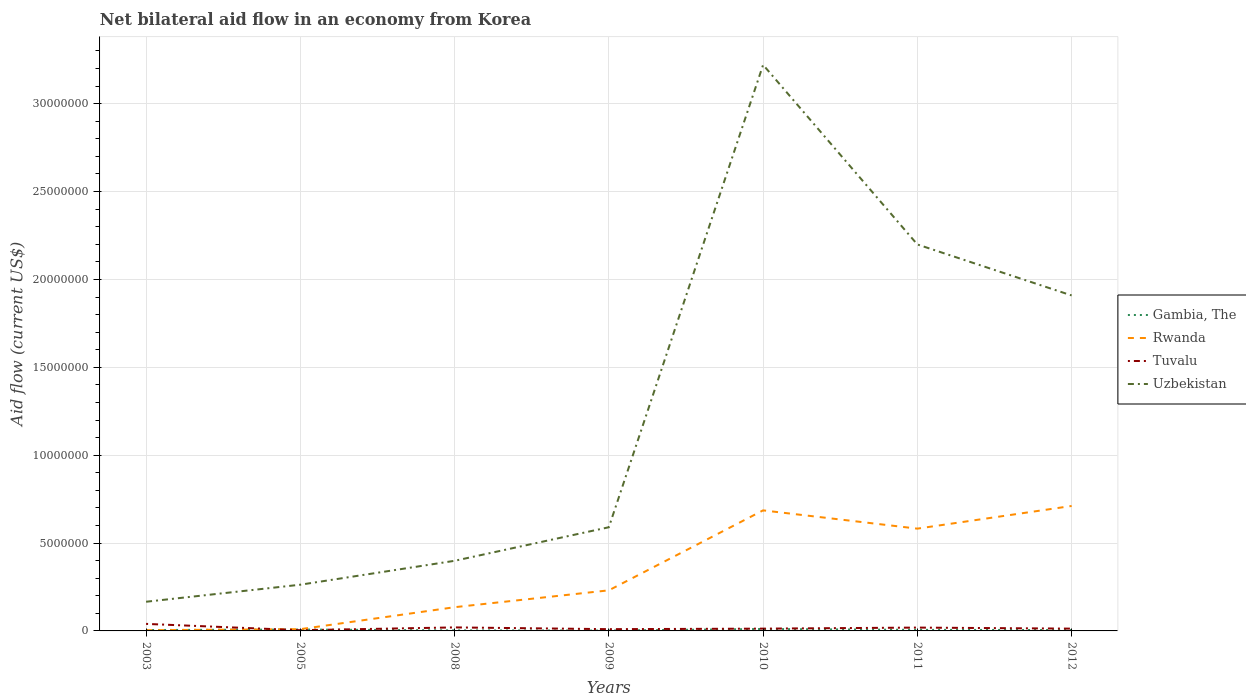How many different coloured lines are there?
Offer a very short reply. 4. Does the line corresponding to Uzbekistan intersect with the line corresponding to Tuvalu?
Keep it short and to the point. No. Across all years, what is the maximum net bilateral aid flow in Uzbekistan?
Make the answer very short. 1.66e+06. In which year was the net bilateral aid flow in Tuvalu maximum?
Keep it short and to the point. 2005. What is the total net bilateral aid flow in Rwanda in the graph?
Ensure brevity in your answer.  -4.47e+06. How many lines are there?
Your answer should be very brief. 4. How many years are there in the graph?
Your answer should be compact. 7. Are the values on the major ticks of Y-axis written in scientific E-notation?
Give a very brief answer. No. Does the graph contain grids?
Your answer should be very brief. Yes. Where does the legend appear in the graph?
Your response must be concise. Center right. How are the legend labels stacked?
Provide a short and direct response. Vertical. What is the title of the graph?
Provide a short and direct response. Net bilateral aid flow in an economy from Korea. Does "Kosovo" appear as one of the legend labels in the graph?
Ensure brevity in your answer.  No. What is the Aid flow (current US$) in Gambia, The in 2003?
Your answer should be very brief. 5.00e+04. What is the Aid flow (current US$) of Rwanda in 2003?
Offer a very short reply. 4.00e+04. What is the Aid flow (current US$) in Uzbekistan in 2003?
Offer a terse response. 1.66e+06. What is the Aid flow (current US$) of Gambia, The in 2005?
Provide a succinct answer. 8.00e+04. What is the Aid flow (current US$) of Uzbekistan in 2005?
Your response must be concise. 2.63e+06. What is the Aid flow (current US$) in Rwanda in 2008?
Ensure brevity in your answer.  1.35e+06. What is the Aid flow (current US$) of Tuvalu in 2008?
Make the answer very short. 2.00e+05. What is the Aid flow (current US$) of Uzbekistan in 2008?
Your answer should be very brief. 3.99e+06. What is the Aid flow (current US$) in Gambia, The in 2009?
Give a very brief answer. 2.00e+04. What is the Aid flow (current US$) of Rwanda in 2009?
Your answer should be compact. 2.31e+06. What is the Aid flow (current US$) in Tuvalu in 2009?
Offer a very short reply. 1.00e+05. What is the Aid flow (current US$) in Uzbekistan in 2009?
Your answer should be compact. 5.90e+06. What is the Aid flow (current US$) in Gambia, The in 2010?
Your answer should be compact. 1.10e+05. What is the Aid flow (current US$) in Rwanda in 2010?
Keep it short and to the point. 6.86e+06. What is the Aid flow (current US$) in Tuvalu in 2010?
Your answer should be compact. 1.30e+05. What is the Aid flow (current US$) of Uzbekistan in 2010?
Your answer should be very brief. 3.22e+07. What is the Aid flow (current US$) of Rwanda in 2011?
Offer a very short reply. 5.82e+06. What is the Aid flow (current US$) of Tuvalu in 2011?
Your answer should be compact. 1.90e+05. What is the Aid flow (current US$) of Uzbekistan in 2011?
Your answer should be compact. 2.20e+07. What is the Aid flow (current US$) in Gambia, The in 2012?
Offer a very short reply. 5.00e+04. What is the Aid flow (current US$) of Rwanda in 2012?
Offer a terse response. 7.11e+06. What is the Aid flow (current US$) in Tuvalu in 2012?
Your answer should be very brief. 1.30e+05. What is the Aid flow (current US$) of Uzbekistan in 2012?
Your answer should be very brief. 1.91e+07. Across all years, what is the maximum Aid flow (current US$) in Rwanda?
Ensure brevity in your answer.  7.11e+06. Across all years, what is the maximum Aid flow (current US$) in Tuvalu?
Ensure brevity in your answer.  4.00e+05. Across all years, what is the maximum Aid flow (current US$) of Uzbekistan?
Make the answer very short. 3.22e+07. Across all years, what is the minimum Aid flow (current US$) of Rwanda?
Provide a succinct answer. 4.00e+04. Across all years, what is the minimum Aid flow (current US$) of Tuvalu?
Offer a terse response. 4.00e+04. Across all years, what is the minimum Aid flow (current US$) in Uzbekistan?
Offer a very short reply. 1.66e+06. What is the total Aid flow (current US$) of Rwanda in the graph?
Offer a very short reply. 2.36e+07. What is the total Aid flow (current US$) in Tuvalu in the graph?
Make the answer very short. 1.19e+06. What is the total Aid flow (current US$) of Uzbekistan in the graph?
Ensure brevity in your answer.  8.75e+07. What is the difference between the Aid flow (current US$) in Rwanda in 2003 and that in 2005?
Your answer should be very brief. -6.00e+04. What is the difference between the Aid flow (current US$) of Uzbekistan in 2003 and that in 2005?
Offer a very short reply. -9.70e+05. What is the difference between the Aid flow (current US$) of Gambia, The in 2003 and that in 2008?
Your answer should be very brief. 2.00e+04. What is the difference between the Aid flow (current US$) in Rwanda in 2003 and that in 2008?
Make the answer very short. -1.31e+06. What is the difference between the Aid flow (current US$) in Uzbekistan in 2003 and that in 2008?
Make the answer very short. -2.33e+06. What is the difference between the Aid flow (current US$) of Rwanda in 2003 and that in 2009?
Your answer should be compact. -2.27e+06. What is the difference between the Aid flow (current US$) of Tuvalu in 2003 and that in 2009?
Provide a succinct answer. 3.00e+05. What is the difference between the Aid flow (current US$) in Uzbekistan in 2003 and that in 2009?
Keep it short and to the point. -4.24e+06. What is the difference between the Aid flow (current US$) in Gambia, The in 2003 and that in 2010?
Make the answer very short. -6.00e+04. What is the difference between the Aid flow (current US$) in Rwanda in 2003 and that in 2010?
Provide a short and direct response. -6.82e+06. What is the difference between the Aid flow (current US$) in Uzbekistan in 2003 and that in 2010?
Offer a terse response. -3.06e+07. What is the difference between the Aid flow (current US$) of Rwanda in 2003 and that in 2011?
Offer a very short reply. -5.78e+06. What is the difference between the Aid flow (current US$) in Tuvalu in 2003 and that in 2011?
Provide a succinct answer. 2.10e+05. What is the difference between the Aid flow (current US$) of Uzbekistan in 2003 and that in 2011?
Ensure brevity in your answer.  -2.03e+07. What is the difference between the Aid flow (current US$) of Rwanda in 2003 and that in 2012?
Provide a short and direct response. -7.07e+06. What is the difference between the Aid flow (current US$) in Tuvalu in 2003 and that in 2012?
Keep it short and to the point. 2.70e+05. What is the difference between the Aid flow (current US$) of Uzbekistan in 2003 and that in 2012?
Offer a very short reply. -1.74e+07. What is the difference between the Aid flow (current US$) in Gambia, The in 2005 and that in 2008?
Provide a succinct answer. 5.00e+04. What is the difference between the Aid flow (current US$) of Rwanda in 2005 and that in 2008?
Your response must be concise. -1.25e+06. What is the difference between the Aid flow (current US$) in Tuvalu in 2005 and that in 2008?
Give a very brief answer. -1.60e+05. What is the difference between the Aid flow (current US$) in Uzbekistan in 2005 and that in 2008?
Provide a succinct answer. -1.36e+06. What is the difference between the Aid flow (current US$) of Gambia, The in 2005 and that in 2009?
Provide a succinct answer. 6.00e+04. What is the difference between the Aid flow (current US$) of Rwanda in 2005 and that in 2009?
Offer a terse response. -2.21e+06. What is the difference between the Aid flow (current US$) in Uzbekistan in 2005 and that in 2009?
Your response must be concise. -3.27e+06. What is the difference between the Aid flow (current US$) of Gambia, The in 2005 and that in 2010?
Your answer should be very brief. -3.00e+04. What is the difference between the Aid flow (current US$) of Rwanda in 2005 and that in 2010?
Keep it short and to the point. -6.76e+06. What is the difference between the Aid flow (current US$) in Tuvalu in 2005 and that in 2010?
Your answer should be compact. -9.00e+04. What is the difference between the Aid flow (current US$) of Uzbekistan in 2005 and that in 2010?
Your answer should be compact. -2.96e+07. What is the difference between the Aid flow (current US$) of Rwanda in 2005 and that in 2011?
Ensure brevity in your answer.  -5.72e+06. What is the difference between the Aid flow (current US$) in Tuvalu in 2005 and that in 2011?
Keep it short and to the point. -1.50e+05. What is the difference between the Aid flow (current US$) in Uzbekistan in 2005 and that in 2011?
Ensure brevity in your answer.  -1.94e+07. What is the difference between the Aid flow (current US$) of Rwanda in 2005 and that in 2012?
Your response must be concise. -7.01e+06. What is the difference between the Aid flow (current US$) in Tuvalu in 2005 and that in 2012?
Offer a very short reply. -9.00e+04. What is the difference between the Aid flow (current US$) in Uzbekistan in 2005 and that in 2012?
Make the answer very short. -1.65e+07. What is the difference between the Aid flow (current US$) of Gambia, The in 2008 and that in 2009?
Keep it short and to the point. 10000. What is the difference between the Aid flow (current US$) of Rwanda in 2008 and that in 2009?
Offer a terse response. -9.60e+05. What is the difference between the Aid flow (current US$) of Tuvalu in 2008 and that in 2009?
Your response must be concise. 1.00e+05. What is the difference between the Aid flow (current US$) in Uzbekistan in 2008 and that in 2009?
Your answer should be compact. -1.91e+06. What is the difference between the Aid flow (current US$) of Rwanda in 2008 and that in 2010?
Your answer should be compact. -5.51e+06. What is the difference between the Aid flow (current US$) of Uzbekistan in 2008 and that in 2010?
Your response must be concise. -2.82e+07. What is the difference between the Aid flow (current US$) of Rwanda in 2008 and that in 2011?
Offer a terse response. -4.47e+06. What is the difference between the Aid flow (current US$) of Tuvalu in 2008 and that in 2011?
Your response must be concise. 10000. What is the difference between the Aid flow (current US$) of Uzbekistan in 2008 and that in 2011?
Provide a short and direct response. -1.80e+07. What is the difference between the Aid flow (current US$) of Gambia, The in 2008 and that in 2012?
Ensure brevity in your answer.  -2.00e+04. What is the difference between the Aid flow (current US$) of Rwanda in 2008 and that in 2012?
Offer a very short reply. -5.76e+06. What is the difference between the Aid flow (current US$) in Tuvalu in 2008 and that in 2012?
Give a very brief answer. 7.00e+04. What is the difference between the Aid flow (current US$) of Uzbekistan in 2008 and that in 2012?
Your answer should be very brief. -1.51e+07. What is the difference between the Aid flow (current US$) of Rwanda in 2009 and that in 2010?
Give a very brief answer. -4.55e+06. What is the difference between the Aid flow (current US$) of Uzbekistan in 2009 and that in 2010?
Provide a succinct answer. -2.63e+07. What is the difference between the Aid flow (current US$) of Gambia, The in 2009 and that in 2011?
Ensure brevity in your answer.  -4.00e+04. What is the difference between the Aid flow (current US$) in Rwanda in 2009 and that in 2011?
Give a very brief answer. -3.51e+06. What is the difference between the Aid flow (current US$) in Tuvalu in 2009 and that in 2011?
Your answer should be compact. -9.00e+04. What is the difference between the Aid flow (current US$) in Uzbekistan in 2009 and that in 2011?
Your answer should be very brief. -1.61e+07. What is the difference between the Aid flow (current US$) in Gambia, The in 2009 and that in 2012?
Offer a very short reply. -3.00e+04. What is the difference between the Aid flow (current US$) of Rwanda in 2009 and that in 2012?
Your answer should be very brief. -4.80e+06. What is the difference between the Aid flow (current US$) in Uzbekistan in 2009 and that in 2012?
Ensure brevity in your answer.  -1.32e+07. What is the difference between the Aid flow (current US$) in Rwanda in 2010 and that in 2011?
Provide a succinct answer. 1.04e+06. What is the difference between the Aid flow (current US$) of Uzbekistan in 2010 and that in 2011?
Provide a short and direct response. 1.02e+07. What is the difference between the Aid flow (current US$) of Gambia, The in 2010 and that in 2012?
Ensure brevity in your answer.  6.00e+04. What is the difference between the Aid flow (current US$) of Rwanda in 2010 and that in 2012?
Provide a short and direct response. -2.50e+05. What is the difference between the Aid flow (current US$) in Uzbekistan in 2010 and that in 2012?
Give a very brief answer. 1.31e+07. What is the difference between the Aid flow (current US$) of Gambia, The in 2011 and that in 2012?
Offer a very short reply. 10000. What is the difference between the Aid flow (current US$) in Rwanda in 2011 and that in 2012?
Make the answer very short. -1.29e+06. What is the difference between the Aid flow (current US$) of Uzbekistan in 2011 and that in 2012?
Offer a terse response. 2.90e+06. What is the difference between the Aid flow (current US$) of Gambia, The in 2003 and the Aid flow (current US$) of Uzbekistan in 2005?
Provide a succinct answer. -2.58e+06. What is the difference between the Aid flow (current US$) of Rwanda in 2003 and the Aid flow (current US$) of Uzbekistan in 2005?
Your response must be concise. -2.59e+06. What is the difference between the Aid flow (current US$) in Tuvalu in 2003 and the Aid flow (current US$) in Uzbekistan in 2005?
Keep it short and to the point. -2.23e+06. What is the difference between the Aid flow (current US$) in Gambia, The in 2003 and the Aid flow (current US$) in Rwanda in 2008?
Give a very brief answer. -1.30e+06. What is the difference between the Aid flow (current US$) of Gambia, The in 2003 and the Aid flow (current US$) of Tuvalu in 2008?
Offer a very short reply. -1.50e+05. What is the difference between the Aid flow (current US$) of Gambia, The in 2003 and the Aid flow (current US$) of Uzbekistan in 2008?
Offer a terse response. -3.94e+06. What is the difference between the Aid flow (current US$) in Rwanda in 2003 and the Aid flow (current US$) in Tuvalu in 2008?
Provide a short and direct response. -1.60e+05. What is the difference between the Aid flow (current US$) in Rwanda in 2003 and the Aid flow (current US$) in Uzbekistan in 2008?
Your response must be concise. -3.95e+06. What is the difference between the Aid flow (current US$) in Tuvalu in 2003 and the Aid flow (current US$) in Uzbekistan in 2008?
Keep it short and to the point. -3.59e+06. What is the difference between the Aid flow (current US$) of Gambia, The in 2003 and the Aid flow (current US$) of Rwanda in 2009?
Keep it short and to the point. -2.26e+06. What is the difference between the Aid flow (current US$) in Gambia, The in 2003 and the Aid flow (current US$) in Uzbekistan in 2009?
Your answer should be compact. -5.85e+06. What is the difference between the Aid flow (current US$) in Rwanda in 2003 and the Aid flow (current US$) in Uzbekistan in 2009?
Offer a terse response. -5.86e+06. What is the difference between the Aid flow (current US$) in Tuvalu in 2003 and the Aid flow (current US$) in Uzbekistan in 2009?
Your answer should be very brief. -5.50e+06. What is the difference between the Aid flow (current US$) of Gambia, The in 2003 and the Aid flow (current US$) of Rwanda in 2010?
Provide a succinct answer. -6.81e+06. What is the difference between the Aid flow (current US$) in Gambia, The in 2003 and the Aid flow (current US$) in Tuvalu in 2010?
Your response must be concise. -8.00e+04. What is the difference between the Aid flow (current US$) of Gambia, The in 2003 and the Aid flow (current US$) of Uzbekistan in 2010?
Provide a succinct answer. -3.22e+07. What is the difference between the Aid flow (current US$) in Rwanda in 2003 and the Aid flow (current US$) in Tuvalu in 2010?
Offer a terse response. -9.00e+04. What is the difference between the Aid flow (current US$) in Rwanda in 2003 and the Aid flow (current US$) in Uzbekistan in 2010?
Keep it short and to the point. -3.22e+07. What is the difference between the Aid flow (current US$) of Tuvalu in 2003 and the Aid flow (current US$) of Uzbekistan in 2010?
Ensure brevity in your answer.  -3.18e+07. What is the difference between the Aid flow (current US$) of Gambia, The in 2003 and the Aid flow (current US$) of Rwanda in 2011?
Provide a short and direct response. -5.77e+06. What is the difference between the Aid flow (current US$) of Gambia, The in 2003 and the Aid flow (current US$) of Tuvalu in 2011?
Your answer should be compact. -1.40e+05. What is the difference between the Aid flow (current US$) in Gambia, The in 2003 and the Aid flow (current US$) in Uzbekistan in 2011?
Ensure brevity in your answer.  -2.19e+07. What is the difference between the Aid flow (current US$) of Rwanda in 2003 and the Aid flow (current US$) of Tuvalu in 2011?
Ensure brevity in your answer.  -1.50e+05. What is the difference between the Aid flow (current US$) of Rwanda in 2003 and the Aid flow (current US$) of Uzbekistan in 2011?
Ensure brevity in your answer.  -2.20e+07. What is the difference between the Aid flow (current US$) in Tuvalu in 2003 and the Aid flow (current US$) in Uzbekistan in 2011?
Offer a terse response. -2.16e+07. What is the difference between the Aid flow (current US$) in Gambia, The in 2003 and the Aid flow (current US$) in Rwanda in 2012?
Your answer should be compact. -7.06e+06. What is the difference between the Aid flow (current US$) in Gambia, The in 2003 and the Aid flow (current US$) in Tuvalu in 2012?
Make the answer very short. -8.00e+04. What is the difference between the Aid flow (current US$) in Gambia, The in 2003 and the Aid flow (current US$) in Uzbekistan in 2012?
Ensure brevity in your answer.  -1.90e+07. What is the difference between the Aid flow (current US$) of Rwanda in 2003 and the Aid flow (current US$) of Uzbekistan in 2012?
Give a very brief answer. -1.90e+07. What is the difference between the Aid flow (current US$) in Tuvalu in 2003 and the Aid flow (current US$) in Uzbekistan in 2012?
Your answer should be very brief. -1.87e+07. What is the difference between the Aid flow (current US$) of Gambia, The in 2005 and the Aid flow (current US$) of Rwanda in 2008?
Ensure brevity in your answer.  -1.27e+06. What is the difference between the Aid flow (current US$) in Gambia, The in 2005 and the Aid flow (current US$) in Tuvalu in 2008?
Provide a short and direct response. -1.20e+05. What is the difference between the Aid flow (current US$) in Gambia, The in 2005 and the Aid flow (current US$) in Uzbekistan in 2008?
Your answer should be very brief. -3.91e+06. What is the difference between the Aid flow (current US$) of Rwanda in 2005 and the Aid flow (current US$) of Uzbekistan in 2008?
Offer a very short reply. -3.89e+06. What is the difference between the Aid flow (current US$) of Tuvalu in 2005 and the Aid flow (current US$) of Uzbekistan in 2008?
Keep it short and to the point. -3.95e+06. What is the difference between the Aid flow (current US$) in Gambia, The in 2005 and the Aid flow (current US$) in Rwanda in 2009?
Offer a very short reply. -2.23e+06. What is the difference between the Aid flow (current US$) of Gambia, The in 2005 and the Aid flow (current US$) of Uzbekistan in 2009?
Provide a short and direct response. -5.82e+06. What is the difference between the Aid flow (current US$) in Rwanda in 2005 and the Aid flow (current US$) in Uzbekistan in 2009?
Your answer should be compact. -5.80e+06. What is the difference between the Aid flow (current US$) of Tuvalu in 2005 and the Aid flow (current US$) of Uzbekistan in 2009?
Your answer should be compact. -5.86e+06. What is the difference between the Aid flow (current US$) in Gambia, The in 2005 and the Aid flow (current US$) in Rwanda in 2010?
Offer a very short reply. -6.78e+06. What is the difference between the Aid flow (current US$) of Gambia, The in 2005 and the Aid flow (current US$) of Tuvalu in 2010?
Keep it short and to the point. -5.00e+04. What is the difference between the Aid flow (current US$) in Gambia, The in 2005 and the Aid flow (current US$) in Uzbekistan in 2010?
Your response must be concise. -3.21e+07. What is the difference between the Aid flow (current US$) in Rwanda in 2005 and the Aid flow (current US$) in Tuvalu in 2010?
Ensure brevity in your answer.  -3.00e+04. What is the difference between the Aid flow (current US$) of Rwanda in 2005 and the Aid flow (current US$) of Uzbekistan in 2010?
Offer a very short reply. -3.21e+07. What is the difference between the Aid flow (current US$) of Tuvalu in 2005 and the Aid flow (current US$) of Uzbekistan in 2010?
Give a very brief answer. -3.22e+07. What is the difference between the Aid flow (current US$) in Gambia, The in 2005 and the Aid flow (current US$) in Rwanda in 2011?
Provide a short and direct response. -5.74e+06. What is the difference between the Aid flow (current US$) of Gambia, The in 2005 and the Aid flow (current US$) of Uzbekistan in 2011?
Your answer should be very brief. -2.19e+07. What is the difference between the Aid flow (current US$) in Rwanda in 2005 and the Aid flow (current US$) in Uzbekistan in 2011?
Your response must be concise. -2.19e+07. What is the difference between the Aid flow (current US$) in Tuvalu in 2005 and the Aid flow (current US$) in Uzbekistan in 2011?
Make the answer very short. -2.20e+07. What is the difference between the Aid flow (current US$) in Gambia, The in 2005 and the Aid flow (current US$) in Rwanda in 2012?
Give a very brief answer. -7.03e+06. What is the difference between the Aid flow (current US$) in Gambia, The in 2005 and the Aid flow (current US$) in Uzbekistan in 2012?
Make the answer very short. -1.90e+07. What is the difference between the Aid flow (current US$) in Rwanda in 2005 and the Aid flow (current US$) in Tuvalu in 2012?
Provide a short and direct response. -3.00e+04. What is the difference between the Aid flow (current US$) in Rwanda in 2005 and the Aid flow (current US$) in Uzbekistan in 2012?
Offer a very short reply. -1.90e+07. What is the difference between the Aid flow (current US$) in Tuvalu in 2005 and the Aid flow (current US$) in Uzbekistan in 2012?
Your answer should be very brief. -1.90e+07. What is the difference between the Aid flow (current US$) in Gambia, The in 2008 and the Aid flow (current US$) in Rwanda in 2009?
Make the answer very short. -2.28e+06. What is the difference between the Aid flow (current US$) in Gambia, The in 2008 and the Aid flow (current US$) in Uzbekistan in 2009?
Your answer should be very brief. -5.87e+06. What is the difference between the Aid flow (current US$) in Rwanda in 2008 and the Aid flow (current US$) in Tuvalu in 2009?
Offer a terse response. 1.25e+06. What is the difference between the Aid flow (current US$) of Rwanda in 2008 and the Aid flow (current US$) of Uzbekistan in 2009?
Offer a terse response. -4.55e+06. What is the difference between the Aid flow (current US$) in Tuvalu in 2008 and the Aid flow (current US$) in Uzbekistan in 2009?
Your answer should be compact. -5.70e+06. What is the difference between the Aid flow (current US$) of Gambia, The in 2008 and the Aid flow (current US$) of Rwanda in 2010?
Your answer should be very brief. -6.83e+06. What is the difference between the Aid flow (current US$) in Gambia, The in 2008 and the Aid flow (current US$) in Uzbekistan in 2010?
Provide a short and direct response. -3.22e+07. What is the difference between the Aid flow (current US$) in Rwanda in 2008 and the Aid flow (current US$) in Tuvalu in 2010?
Provide a short and direct response. 1.22e+06. What is the difference between the Aid flow (current US$) of Rwanda in 2008 and the Aid flow (current US$) of Uzbekistan in 2010?
Offer a terse response. -3.09e+07. What is the difference between the Aid flow (current US$) of Tuvalu in 2008 and the Aid flow (current US$) of Uzbekistan in 2010?
Your answer should be very brief. -3.20e+07. What is the difference between the Aid flow (current US$) in Gambia, The in 2008 and the Aid flow (current US$) in Rwanda in 2011?
Offer a terse response. -5.79e+06. What is the difference between the Aid flow (current US$) in Gambia, The in 2008 and the Aid flow (current US$) in Uzbekistan in 2011?
Ensure brevity in your answer.  -2.20e+07. What is the difference between the Aid flow (current US$) of Rwanda in 2008 and the Aid flow (current US$) of Tuvalu in 2011?
Offer a very short reply. 1.16e+06. What is the difference between the Aid flow (current US$) of Rwanda in 2008 and the Aid flow (current US$) of Uzbekistan in 2011?
Provide a succinct answer. -2.06e+07. What is the difference between the Aid flow (current US$) of Tuvalu in 2008 and the Aid flow (current US$) of Uzbekistan in 2011?
Give a very brief answer. -2.18e+07. What is the difference between the Aid flow (current US$) in Gambia, The in 2008 and the Aid flow (current US$) in Rwanda in 2012?
Make the answer very short. -7.08e+06. What is the difference between the Aid flow (current US$) of Gambia, The in 2008 and the Aid flow (current US$) of Uzbekistan in 2012?
Provide a short and direct response. -1.91e+07. What is the difference between the Aid flow (current US$) of Rwanda in 2008 and the Aid flow (current US$) of Tuvalu in 2012?
Keep it short and to the point. 1.22e+06. What is the difference between the Aid flow (current US$) in Rwanda in 2008 and the Aid flow (current US$) in Uzbekistan in 2012?
Ensure brevity in your answer.  -1.77e+07. What is the difference between the Aid flow (current US$) in Tuvalu in 2008 and the Aid flow (current US$) in Uzbekistan in 2012?
Provide a succinct answer. -1.89e+07. What is the difference between the Aid flow (current US$) of Gambia, The in 2009 and the Aid flow (current US$) of Rwanda in 2010?
Your response must be concise. -6.84e+06. What is the difference between the Aid flow (current US$) of Gambia, The in 2009 and the Aid flow (current US$) of Uzbekistan in 2010?
Keep it short and to the point. -3.22e+07. What is the difference between the Aid flow (current US$) in Rwanda in 2009 and the Aid flow (current US$) in Tuvalu in 2010?
Provide a short and direct response. 2.18e+06. What is the difference between the Aid flow (current US$) in Rwanda in 2009 and the Aid flow (current US$) in Uzbekistan in 2010?
Give a very brief answer. -2.99e+07. What is the difference between the Aid flow (current US$) in Tuvalu in 2009 and the Aid flow (current US$) in Uzbekistan in 2010?
Make the answer very short. -3.21e+07. What is the difference between the Aid flow (current US$) in Gambia, The in 2009 and the Aid flow (current US$) in Rwanda in 2011?
Keep it short and to the point. -5.80e+06. What is the difference between the Aid flow (current US$) in Gambia, The in 2009 and the Aid flow (current US$) in Tuvalu in 2011?
Your response must be concise. -1.70e+05. What is the difference between the Aid flow (current US$) of Gambia, The in 2009 and the Aid flow (current US$) of Uzbekistan in 2011?
Keep it short and to the point. -2.20e+07. What is the difference between the Aid flow (current US$) in Rwanda in 2009 and the Aid flow (current US$) in Tuvalu in 2011?
Your answer should be compact. 2.12e+06. What is the difference between the Aid flow (current US$) of Rwanda in 2009 and the Aid flow (current US$) of Uzbekistan in 2011?
Provide a short and direct response. -1.97e+07. What is the difference between the Aid flow (current US$) in Tuvalu in 2009 and the Aid flow (current US$) in Uzbekistan in 2011?
Your answer should be very brief. -2.19e+07. What is the difference between the Aid flow (current US$) of Gambia, The in 2009 and the Aid flow (current US$) of Rwanda in 2012?
Give a very brief answer. -7.09e+06. What is the difference between the Aid flow (current US$) of Gambia, The in 2009 and the Aid flow (current US$) of Tuvalu in 2012?
Offer a very short reply. -1.10e+05. What is the difference between the Aid flow (current US$) of Gambia, The in 2009 and the Aid flow (current US$) of Uzbekistan in 2012?
Offer a very short reply. -1.91e+07. What is the difference between the Aid flow (current US$) of Rwanda in 2009 and the Aid flow (current US$) of Tuvalu in 2012?
Your answer should be compact. 2.18e+06. What is the difference between the Aid flow (current US$) in Rwanda in 2009 and the Aid flow (current US$) in Uzbekistan in 2012?
Provide a short and direct response. -1.68e+07. What is the difference between the Aid flow (current US$) of Tuvalu in 2009 and the Aid flow (current US$) of Uzbekistan in 2012?
Keep it short and to the point. -1.90e+07. What is the difference between the Aid flow (current US$) in Gambia, The in 2010 and the Aid flow (current US$) in Rwanda in 2011?
Your answer should be very brief. -5.71e+06. What is the difference between the Aid flow (current US$) in Gambia, The in 2010 and the Aid flow (current US$) in Tuvalu in 2011?
Ensure brevity in your answer.  -8.00e+04. What is the difference between the Aid flow (current US$) in Gambia, The in 2010 and the Aid flow (current US$) in Uzbekistan in 2011?
Make the answer very short. -2.19e+07. What is the difference between the Aid flow (current US$) of Rwanda in 2010 and the Aid flow (current US$) of Tuvalu in 2011?
Provide a succinct answer. 6.67e+06. What is the difference between the Aid flow (current US$) of Rwanda in 2010 and the Aid flow (current US$) of Uzbekistan in 2011?
Ensure brevity in your answer.  -1.51e+07. What is the difference between the Aid flow (current US$) of Tuvalu in 2010 and the Aid flow (current US$) of Uzbekistan in 2011?
Ensure brevity in your answer.  -2.19e+07. What is the difference between the Aid flow (current US$) in Gambia, The in 2010 and the Aid flow (current US$) in Rwanda in 2012?
Your answer should be compact. -7.00e+06. What is the difference between the Aid flow (current US$) of Gambia, The in 2010 and the Aid flow (current US$) of Uzbekistan in 2012?
Make the answer very short. -1.90e+07. What is the difference between the Aid flow (current US$) of Rwanda in 2010 and the Aid flow (current US$) of Tuvalu in 2012?
Make the answer very short. 6.73e+06. What is the difference between the Aid flow (current US$) of Rwanda in 2010 and the Aid flow (current US$) of Uzbekistan in 2012?
Provide a short and direct response. -1.22e+07. What is the difference between the Aid flow (current US$) of Tuvalu in 2010 and the Aid flow (current US$) of Uzbekistan in 2012?
Give a very brief answer. -1.90e+07. What is the difference between the Aid flow (current US$) in Gambia, The in 2011 and the Aid flow (current US$) in Rwanda in 2012?
Your answer should be very brief. -7.05e+06. What is the difference between the Aid flow (current US$) in Gambia, The in 2011 and the Aid flow (current US$) in Uzbekistan in 2012?
Provide a short and direct response. -1.90e+07. What is the difference between the Aid flow (current US$) of Rwanda in 2011 and the Aid flow (current US$) of Tuvalu in 2012?
Your response must be concise. 5.69e+06. What is the difference between the Aid flow (current US$) of Rwanda in 2011 and the Aid flow (current US$) of Uzbekistan in 2012?
Your response must be concise. -1.33e+07. What is the difference between the Aid flow (current US$) of Tuvalu in 2011 and the Aid flow (current US$) of Uzbekistan in 2012?
Provide a short and direct response. -1.89e+07. What is the average Aid flow (current US$) in Gambia, The per year?
Give a very brief answer. 5.71e+04. What is the average Aid flow (current US$) of Rwanda per year?
Provide a short and direct response. 3.37e+06. What is the average Aid flow (current US$) in Uzbekistan per year?
Ensure brevity in your answer.  1.25e+07. In the year 2003, what is the difference between the Aid flow (current US$) in Gambia, The and Aid flow (current US$) in Rwanda?
Your answer should be very brief. 10000. In the year 2003, what is the difference between the Aid flow (current US$) in Gambia, The and Aid flow (current US$) in Tuvalu?
Ensure brevity in your answer.  -3.50e+05. In the year 2003, what is the difference between the Aid flow (current US$) in Gambia, The and Aid flow (current US$) in Uzbekistan?
Make the answer very short. -1.61e+06. In the year 2003, what is the difference between the Aid flow (current US$) in Rwanda and Aid flow (current US$) in Tuvalu?
Offer a terse response. -3.60e+05. In the year 2003, what is the difference between the Aid flow (current US$) of Rwanda and Aid flow (current US$) of Uzbekistan?
Provide a short and direct response. -1.62e+06. In the year 2003, what is the difference between the Aid flow (current US$) in Tuvalu and Aid flow (current US$) in Uzbekistan?
Provide a short and direct response. -1.26e+06. In the year 2005, what is the difference between the Aid flow (current US$) of Gambia, The and Aid flow (current US$) of Tuvalu?
Provide a succinct answer. 4.00e+04. In the year 2005, what is the difference between the Aid flow (current US$) in Gambia, The and Aid flow (current US$) in Uzbekistan?
Your answer should be very brief. -2.55e+06. In the year 2005, what is the difference between the Aid flow (current US$) in Rwanda and Aid flow (current US$) in Tuvalu?
Offer a terse response. 6.00e+04. In the year 2005, what is the difference between the Aid flow (current US$) in Rwanda and Aid flow (current US$) in Uzbekistan?
Give a very brief answer. -2.53e+06. In the year 2005, what is the difference between the Aid flow (current US$) in Tuvalu and Aid flow (current US$) in Uzbekistan?
Your answer should be very brief. -2.59e+06. In the year 2008, what is the difference between the Aid flow (current US$) of Gambia, The and Aid flow (current US$) of Rwanda?
Your answer should be compact. -1.32e+06. In the year 2008, what is the difference between the Aid flow (current US$) in Gambia, The and Aid flow (current US$) in Tuvalu?
Provide a short and direct response. -1.70e+05. In the year 2008, what is the difference between the Aid flow (current US$) in Gambia, The and Aid flow (current US$) in Uzbekistan?
Ensure brevity in your answer.  -3.96e+06. In the year 2008, what is the difference between the Aid flow (current US$) of Rwanda and Aid flow (current US$) of Tuvalu?
Provide a short and direct response. 1.15e+06. In the year 2008, what is the difference between the Aid flow (current US$) in Rwanda and Aid flow (current US$) in Uzbekistan?
Offer a terse response. -2.64e+06. In the year 2008, what is the difference between the Aid flow (current US$) in Tuvalu and Aid flow (current US$) in Uzbekistan?
Your response must be concise. -3.79e+06. In the year 2009, what is the difference between the Aid flow (current US$) of Gambia, The and Aid flow (current US$) of Rwanda?
Ensure brevity in your answer.  -2.29e+06. In the year 2009, what is the difference between the Aid flow (current US$) in Gambia, The and Aid flow (current US$) in Uzbekistan?
Provide a succinct answer. -5.88e+06. In the year 2009, what is the difference between the Aid flow (current US$) in Rwanda and Aid flow (current US$) in Tuvalu?
Your response must be concise. 2.21e+06. In the year 2009, what is the difference between the Aid flow (current US$) of Rwanda and Aid flow (current US$) of Uzbekistan?
Your answer should be compact. -3.59e+06. In the year 2009, what is the difference between the Aid flow (current US$) of Tuvalu and Aid flow (current US$) of Uzbekistan?
Ensure brevity in your answer.  -5.80e+06. In the year 2010, what is the difference between the Aid flow (current US$) of Gambia, The and Aid flow (current US$) of Rwanda?
Give a very brief answer. -6.75e+06. In the year 2010, what is the difference between the Aid flow (current US$) of Gambia, The and Aid flow (current US$) of Uzbekistan?
Keep it short and to the point. -3.21e+07. In the year 2010, what is the difference between the Aid flow (current US$) in Rwanda and Aid flow (current US$) in Tuvalu?
Provide a short and direct response. 6.73e+06. In the year 2010, what is the difference between the Aid flow (current US$) in Rwanda and Aid flow (current US$) in Uzbekistan?
Keep it short and to the point. -2.54e+07. In the year 2010, what is the difference between the Aid flow (current US$) in Tuvalu and Aid flow (current US$) in Uzbekistan?
Ensure brevity in your answer.  -3.21e+07. In the year 2011, what is the difference between the Aid flow (current US$) in Gambia, The and Aid flow (current US$) in Rwanda?
Ensure brevity in your answer.  -5.76e+06. In the year 2011, what is the difference between the Aid flow (current US$) in Gambia, The and Aid flow (current US$) in Tuvalu?
Your response must be concise. -1.30e+05. In the year 2011, what is the difference between the Aid flow (current US$) of Gambia, The and Aid flow (current US$) of Uzbekistan?
Provide a short and direct response. -2.19e+07. In the year 2011, what is the difference between the Aid flow (current US$) of Rwanda and Aid flow (current US$) of Tuvalu?
Provide a short and direct response. 5.63e+06. In the year 2011, what is the difference between the Aid flow (current US$) of Rwanda and Aid flow (current US$) of Uzbekistan?
Offer a very short reply. -1.62e+07. In the year 2011, what is the difference between the Aid flow (current US$) of Tuvalu and Aid flow (current US$) of Uzbekistan?
Your response must be concise. -2.18e+07. In the year 2012, what is the difference between the Aid flow (current US$) in Gambia, The and Aid flow (current US$) in Rwanda?
Give a very brief answer. -7.06e+06. In the year 2012, what is the difference between the Aid flow (current US$) of Gambia, The and Aid flow (current US$) of Tuvalu?
Provide a succinct answer. -8.00e+04. In the year 2012, what is the difference between the Aid flow (current US$) in Gambia, The and Aid flow (current US$) in Uzbekistan?
Provide a short and direct response. -1.90e+07. In the year 2012, what is the difference between the Aid flow (current US$) of Rwanda and Aid flow (current US$) of Tuvalu?
Your response must be concise. 6.98e+06. In the year 2012, what is the difference between the Aid flow (current US$) in Rwanda and Aid flow (current US$) in Uzbekistan?
Your response must be concise. -1.20e+07. In the year 2012, what is the difference between the Aid flow (current US$) in Tuvalu and Aid flow (current US$) in Uzbekistan?
Your response must be concise. -1.90e+07. What is the ratio of the Aid flow (current US$) in Gambia, The in 2003 to that in 2005?
Your answer should be very brief. 0.62. What is the ratio of the Aid flow (current US$) of Tuvalu in 2003 to that in 2005?
Ensure brevity in your answer.  10. What is the ratio of the Aid flow (current US$) in Uzbekistan in 2003 to that in 2005?
Your answer should be very brief. 0.63. What is the ratio of the Aid flow (current US$) in Rwanda in 2003 to that in 2008?
Offer a very short reply. 0.03. What is the ratio of the Aid flow (current US$) in Uzbekistan in 2003 to that in 2008?
Give a very brief answer. 0.42. What is the ratio of the Aid flow (current US$) of Gambia, The in 2003 to that in 2009?
Give a very brief answer. 2.5. What is the ratio of the Aid flow (current US$) of Rwanda in 2003 to that in 2009?
Your answer should be compact. 0.02. What is the ratio of the Aid flow (current US$) of Uzbekistan in 2003 to that in 2009?
Provide a succinct answer. 0.28. What is the ratio of the Aid flow (current US$) of Gambia, The in 2003 to that in 2010?
Your answer should be very brief. 0.45. What is the ratio of the Aid flow (current US$) of Rwanda in 2003 to that in 2010?
Make the answer very short. 0.01. What is the ratio of the Aid flow (current US$) of Tuvalu in 2003 to that in 2010?
Your answer should be compact. 3.08. What is the ratio of the Aid flow (current US$) of Uzbekistan in 2003 to that in 2010?
Keep it short and to the point. 0.05. What is the ratio of the Aid flow (current US$) of Rwanda in 2003 to that in 2011?
Make the answer very short. 0.01. What is the ratio of the Aid flow (current US$) in Tuvalu in 2003 to that in 2011?
Provide a succinct answer. 2.11. What is the ratio of the Aid flow (current US$) of Uzbekistan in 2003 to that in 2011?
Provide a succinct answer. 0.08. What is the ratio of the Aid flow (current US$) in Rwanda in 2003 to that in 2012?
Provide a succinct answer. 0.01. What is the ratio of the Aid flow (current US$) of Tuvalu in 2003 to that in 2012?
Your response must be concise. 3.08. What is the ratio of the Aid flow (current US$) of Uzbekistan in 2003 to that in 2012?
Provide a succinct answer. 0.09. What is the ratio of the Aid flow (current US$) in Gambia, The in 2005 to that in 2008?
Your answer should be very brief. 2.67. What is the ratio of the Aid flow (current US$) of Rwanda in 2005 to that in 2008?
Your response must be concise. 0.07. What is the ratio of the Aid flow (current US$) in Uzbekistan in 2005 to that in 2008?
Keep it short and to the point. 0.66. What is the ratio of the Aid flow (current US$) in Gambia, The in 2005 to that in 2009?
Your answer should be very brief. 4. What is the ratio of the Aid flow (current US$) of Rwanda in 2005 to that in 2009?
Your response must be concise. 0.04. What is the ratio of the Aid flow (current US$) in Tuvalu in 2005 to that in 2009?
Provide a succinct answer. 0.4. What is the ratio of the Aid flow (current US$) of Uzbekistan in 2005 to that in 2009?
Your response must be concise. 0.45. What is the ratio of the Aid flow (current US$) of Gambia, The in 2005 to that in 2010?
Your answer should be very brief. 0.73. What is the ratio of the Aid flow (current US$) of Rwanda in 2005 to that in 2010?
Keep it short and to the point. 0.01. What is the ratio of the Aid flow (current US$) in Tuvalu in 2005 to that in 2010?
Your answer should be very brief. 0.31. What is the ratio of the Aid flow (current US$) in Uzbekistan in 2005 to that in 2010?
Provide a succinct answer. 0.08. What is the ratio of the Aid flow (current US$) in Rwanda in 2005 to that in 2011?
Provide a succinct answer. 0.02. What is the ratio of the Aid flow (current US$) of Tuvalu in 2005 to that in 2011?
Offer a terse response. 0.21. What is the ratio of the Aid flow (current US$) in Uzbekistan in 2005 to that in 2011?
Keep it short and to the point. 0.12. What is the ratio of the Aid flow (current US$) of Rwanda in 2005 to that in 2012?
Make the answer very short. 0.01. What is the ratio of the Aid flow (current US$) of Tuvalu in 2005 to that in 2012?
Give a very brief answer. 0.31. What is the ratio of the Aid flow (current US$) in Uzbekistan in 2005 to that in 2012?
Provide a succinct answer. 0.14. What is the ratio of the Aid flow (current US$) in Gambia, The in 2008 to that in 2009?
Offer a very short reply. 1.5. What is the ratio of the Aid flow (current US$) of Rwanda in 2008 to that in 2009?
Your answer should be very brief. 0.58. What is the ratio of the Aid flow (current US$) in Uzbekistan in 2008 to that in 2009?
Your response must be concise. 0.68. What is the ratio of the Aid flow (current US$) in Gambia, The in 2008 to that in 2010?
Provide a short and direct response. 0.27. What is the ratio of the Aid flow (current US$) of Rwanda in 2008 to that in 2010?
Keep it short and to the point. 0.2. What is the ratio of the Aid flow (current US$) of Tuvalu in 2008 to that in 2010?
Ensure brevity in your answer.  1.54. What is the ratio of the Aid flow (current US$) of Uzbekistan in 2008 to that in 2010?
Provide a succinct answer. 0.12. What is the ratio of the Aid flow (current US$) of Gambia, The in 2008 to that in 2011?
Ensure brevity in your answer.  0.5. What is the ratio of the Aid flow (current US$) in Rwanda in 2008 to that in 2011?
Your response must be concise. 0.23. What is the ratio of the Aid flow (current US$) of Tuvalu in 2008 to that in 2011?
Offer a terse response. 1.05. What is the ratio of the Aid flow (current US$) in Uzbekistan in 2008 to that in 2011?
Your answer should be compact. 0.18. What is the ratio of the Aid flow (current US$) in Gambia, The in 2008 to that in 2012?
Keep it short and to the point. 0.6. What is the ratio of the Aid flow (current US$) in Rwanda in 2008 to that in 2012?
Ensure brevity in your answer.  0.19. What is the ratio of the Aid flow (current US$) in Tuvalu in 2008 to that in 2012?
Offer a terse response. 1.54. What is the ratio of the Aid flow (current US$) in Uzbekistan in 2008 to that in 2012?
Your answer should be very brief. 0.21. What is the ratio of the Aid flow (current US$) of Gambia, The in 2009 to that in 2010?
Give a very brief answer. 0.18. What is the ratio of the Aid flow (current US$) of Rwanda in 2009 to that in 2010?
Your answer should be very brief. 0.34. What is the ratio of the Aid flow (current US$) in Tuvalu in 2009 to that in 2010?
Provide a short and direct response. 0.77. What is the ratio of the Aid flow (current US$) in Uzbekistan in 2009 to that in 2010?
Your answer should be very brief. 0.18. What is the ratio of the Aid flow (current US$) in Gambia, The in 2009 to that in 2011?
Your response must be concise. 0.33. What is the ratio of the Aid flow (current US$) in Rwanda in 2009 to that in 2011?
Offer a very short reply. 0.4. What is the ratio of the Aid flow (current US$) of Tuvalu in 2009 to that in 2011?
Make the answer very short. 0.53. What is the ratio of the Aid flow (current US$) of Uzbekistan in 2009 to that in 2011?
Provide a succinct answer. 0.27. What is the ratio of the Aid flow (current US$) in Gambia, The in 2009 to that in 2012?
Offer a very short reply. 0.4. What is the ratio of the Aid flow (current US$) in Rwanda in 2009 to that in 2012?
Provide a short and direct response. 0.32. What is the ratio of the Aid flow (current US$) of Tuvalu in 2009 to that in 2012?
Your answer should be very brief. 0.77. What is the ratio of the Aid flow (current US$) of Uzbekistan in 2009 to that in 2012?
Your answer should be very brief. 0.31. What is the ratio of the Aid flow (current US$) of Gambia, The in 2010 to that in 2011?
Your response must be concise. 1.83. What is the ratio of the Aid flow (current US$) of Rwanda in 2010 to that in 2011?
Make the answer very short. 1.18. What is the ratio of the Aid flow (current US$) of Tuvalu in 2010 to that in 2011?
Your answer should be compact. 0.68. What is the ratio of the Aid flow (current US$) in Uzbekistan in 2010 to that in 2011?
Make the answer very short. 1.46. What is the ratio of the Aid flow (current US$) in Gambia, The in 2010 to that in 2012?
Offer a terse response. 2.2. What is the ratio of the Aid flow (current US$) of Rwanda in 2010 to that in 2012?
Offer a very short reply. 0.96. What is the ratio of the Aid flow (current US$) of Tuvalu in 2010 to that in 2012?
Provide a succinct answer. 1. What is the ratio of the Aid flow (current US$) of Uzbekistan in 2010 to that in 2012?
Your answer should be compact. 1.69. What is the ratio of the Aid flow (current US$) in Gambia, The in 2011 to that in 2012?
Your answer should be compact. 1.2. What is the ratio of the Aid flow (current US$) in Rwanda in 2011 to that in 2012?
Give a very brief answer. 0.82. What is the ratio of the Aid flow (current US$) of Tuvalu in 2011 to that in 2012?
Provide a succinct answer. 1.46. What is the ratio of the Aid flow (current US$) of Uzbekistan in 2011 to that in 2012?
Give a very brief answer. 1.15. What is the difference between the highest and the second highest Aid flow (current US$) in Gambia, The?
Offer a terse response. 3.00e+04. What is the difference between the highest and the second highest Aid flow (current US$) in Uzbekistan?
Provide a succinct answer. 1.02e+07. What is the difference between the highest and the lowest Aid flow (current US$) in Rwanda?
Your response must be concise. 7.07e+06. What is the difference between the highest and the lowest Aid flow (current US$) in Tuvalu?
Give a very brief answer. 3.60e+05. What is the difference between the highest and the lowest Aid flow (current US$) in Uzbekistan?
Make the answer very short. 3.06e+07. 